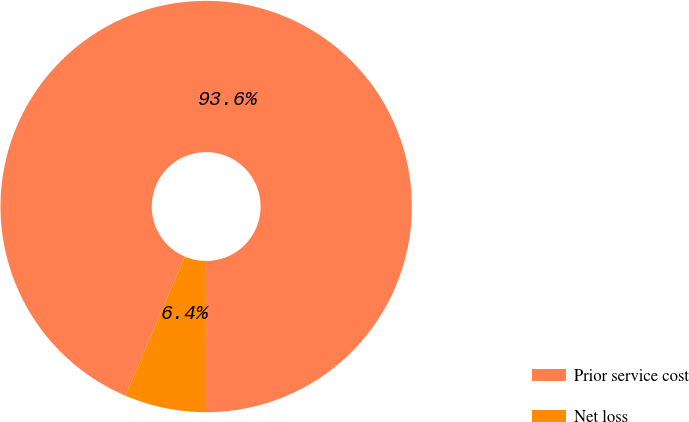Convert chart. <chart><loc_0><loc_0><loc_500><loc_500><pie_chart><fcel>Prior service cost<fcel>Net loss<nl><fcel>93.59%<fcel>6.41%<nl></chart> 